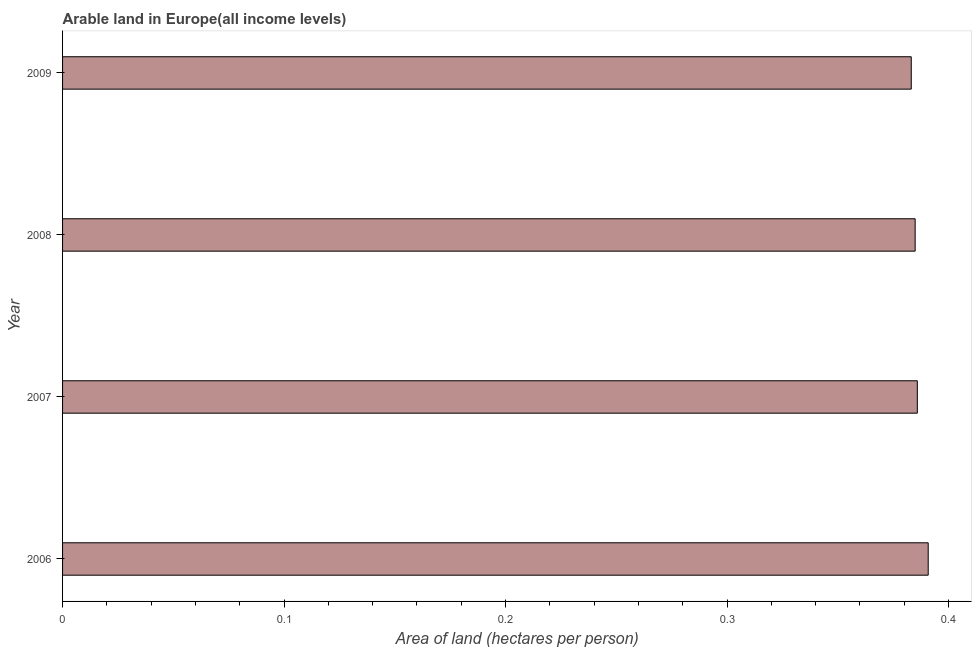Does the graph contain grids?
Provide a succinct answer. No. What is the title of the graph?
Provide a short and direct response. Arable land in Europe(all income levels). What is the label or title of the X-axis?
Provide a succinct answer. Area of land (hectares per person). What is the area of arable land in 2006?
Make the answer very short. 0.39. Across all years, what is the maximum area of arable land?
Offer a terse response. 0.39. Across all years, what is the minimum area of arable land?
Offer a very short reply. 0.38. In which year was the area of arable land maximum?
Make the answer very short. 2006. In which year was the area of arable land minimum?
Give a very brief answer. 2009. What is the sum of the area of arable land?
Keep it short and to the point. 1.54. What is the difference between the area of arable land in 2006 and 2009?
Ensure brevity in your answer.  0.01. What is the average area of arable land per year?
Provide a short and direct response. 0.39. What is the median area of arable land?
Offer a terse response. 0.39. Is the area of arable land in 2008 less than that in 2009?
Provide a succinct answer. No. Is the difference between the area of arable land in 2006 and 2008 greater than the difference between any two years?
Provide a short and direct response. No. What is the difference between the highest and the second highest area of arable land?
Keep it short and to the point. 0.01. Is the sum of the area of arable land in 2006 and 2008 greater than the maximum area of arable land across all years?
Provide a succinct answer. Yes. What is the difference between the highest and the lowest area of arable land?
Make the answer very short. 0.01. In how many years, is the area of arable land greater than the average area of arable land taken over all years?
Make the answer very short. 1. How many bars are there?
Make the answer very short. 4. Are all the bars in the graph horizontal?
Your response must be concise. Yes. How many years are there in the graph?
Make the answer very short. 4. Are the values on the major ticks of X-axis written in scientific E-notation?
Offer a terse response. No. What is the Area of land (hectares per person) in 2006?
Offer a terse response. 0.39. What is the Area of land (hectares per person) in 2007?
Provide a short and direct response. 0.39. What is the Area of land (hectares per person) in 2008?
Provide a succinct answer. 0.38. What is the Area of land (hectares per person) of 2009?
Your answer should be very brief. 0.38. What is the difference between the Area of land (hectares per person) in 2006 and 2007?
Your answer should be very brief. 0. What is the difference between the Area of land (hectares per person) in 2006 and 2008?
Make the answer very short. 0.01. What is the difference between the Area of land (hectares per person) in 2006 and 2009?
Give a very brief answer. 0.01. What is the difference between the Area of land (hectares per person) in 2007 and 2008?
Provide a succinct answer. 0. What is the difference between the Area of land (hectares per person) in 2007 and 2009?
Make the answer very short. 0. What is the difference between the Area of land (hectares per person) in 2008 and 2009?
Your response must be concise. 0. What is the ratio of the Area of land (hectares per person) in 2006 to that in 2008?
Ensure brevity in your answer.  1.01. What is the ratio of the Area of land (hectares per person) in 2007 to that in 2008?
Your answer should be compact. 1. 